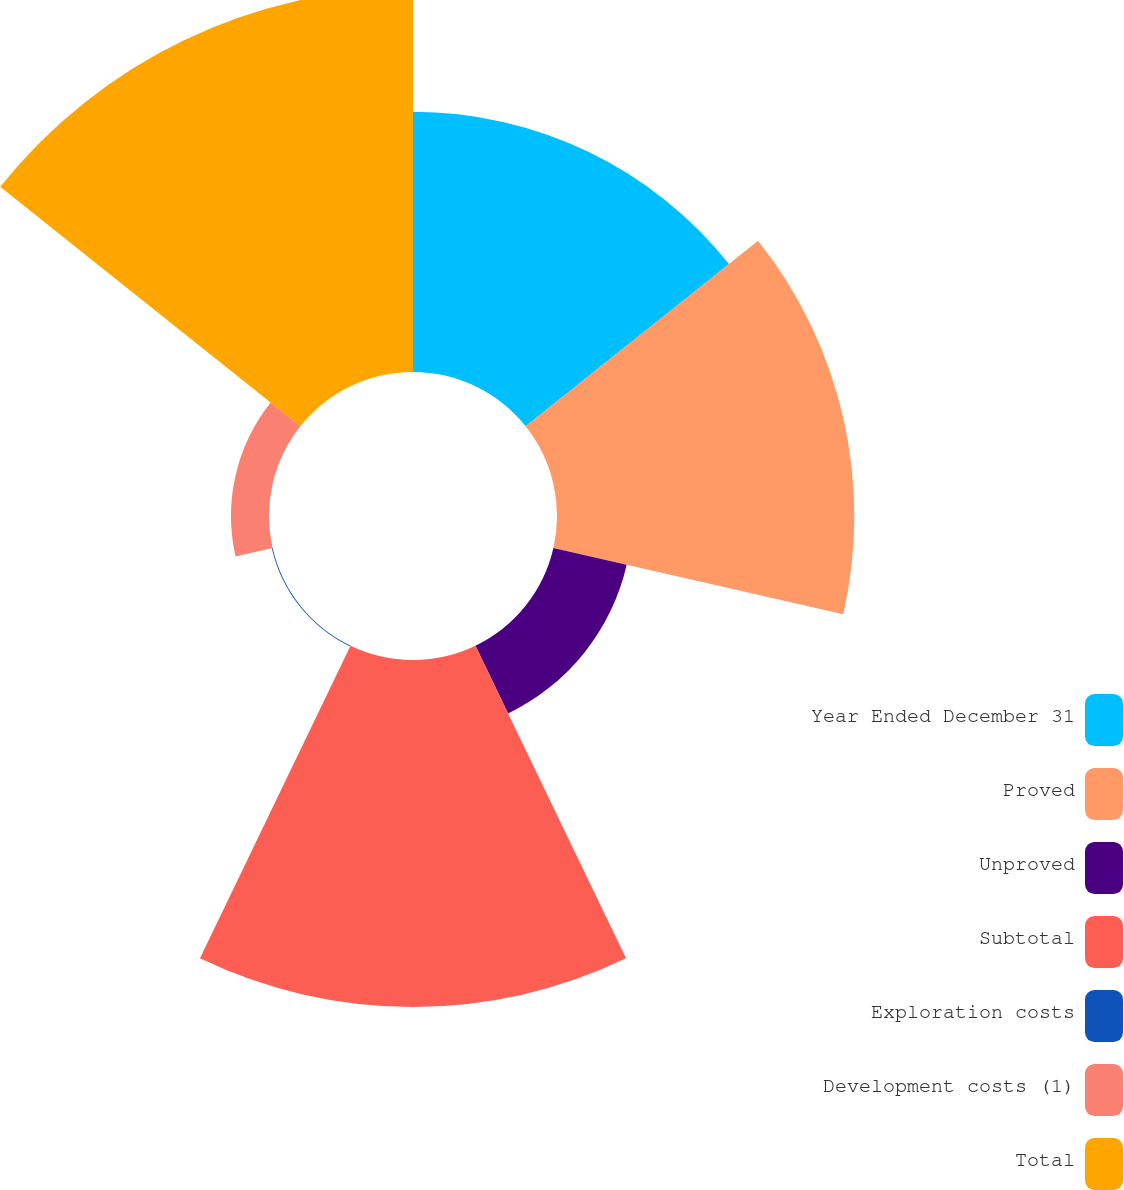Convert chart to OTSL. <chart><loc_0><loc_0><loc_500><loc_500><pie_chart><fcel>Year Ended December 31<fcel>Proved<fcel>Unproved<fcel>Subtotal<fcel>Exploration costs<fcel>Development costs (1)<fcel>Total<nl><fcel>18.55%<fcel>21.2%<fcel>5.36%<fcel>24.74%<fcel>0.06%<fcel>2.71%<fcel>27.38%<nl></chart> 